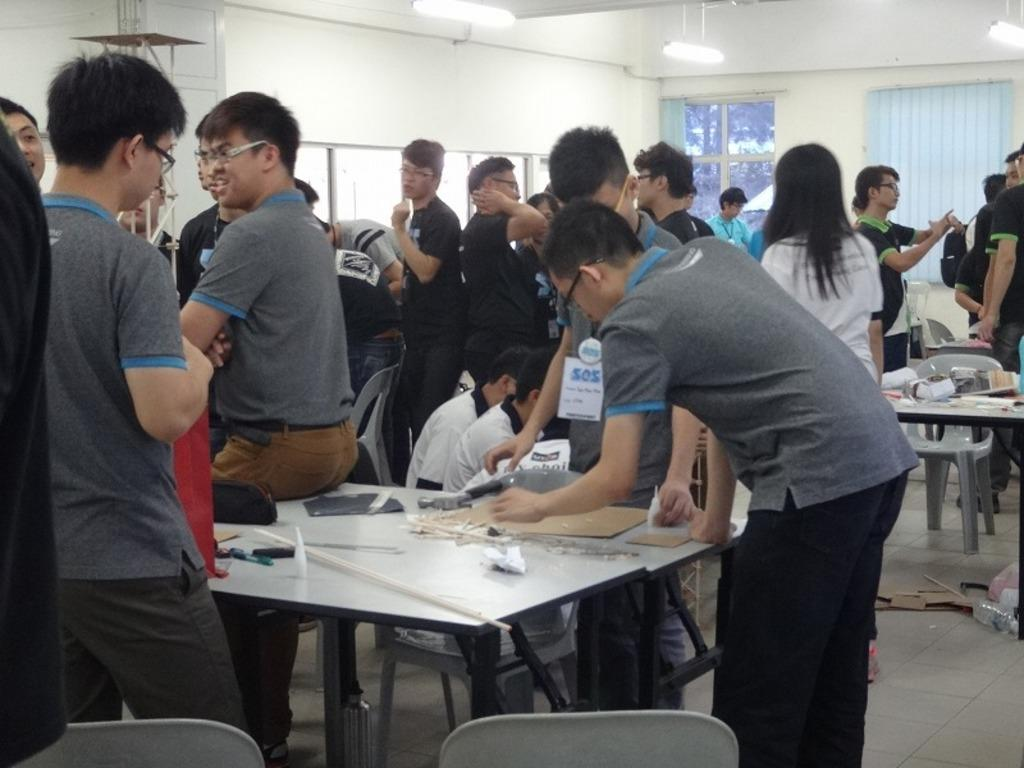What are the people in the image doing? People are standing around the table and some are sitting in chairs. Can you describe the objects in the background? There is a glass and a light in the background. How many sisters are present in the image? There is no information about sisters in the image, so we cannot determine the number of sisters present. 